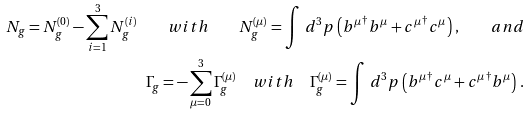Convert formula to latex. <formula><loc_0><loc_0><loc_500><loc_500>N _ { g } = N _ { g } ^ { ( 0 ) } - \sum _ { i = 1 } ^ { 3 } N _ { g } ^ { ( i ) } \quad w i t h \quad N _ { g } ^ { ( \mu ) } = \int \, d ^ { 3 } p \, \left ( { b ^ { \mu } } ^ { \dagger } b ^ { \mu } + { c ^ { \mu } } ^ { \dagger } c ^ { \mu } \right ) \, , \quad a n d \\ \Gamma _ { g } = - \sum _ { \mu = 0 } ^ { 3 } \Gamma _ { g } ^ { ( \mu ) } \quad w i t h \quad \Gamma _ { g } ^ { ( \mu ) } = \int \, d ^ { 3 } p \, \left ( { b ^ { \mu } } ^ { \dagger } c ^ { \mu } + { c ^ { \mu } } ^ { \dagger } b ^ { \mu } \right ) \, .</formula> 